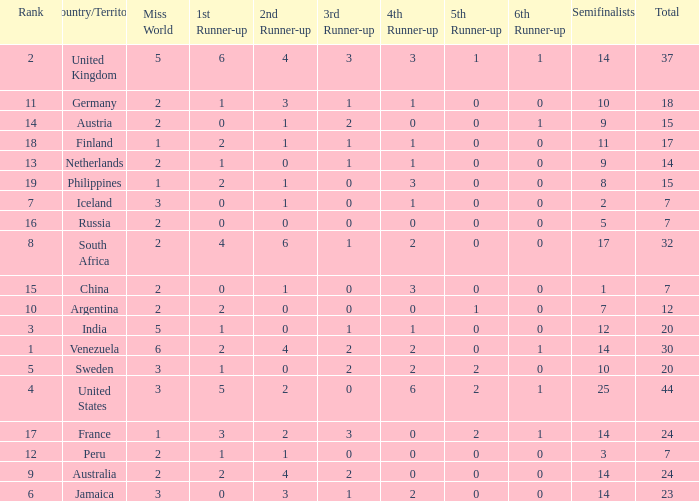Which countries have a 5th runner-up ranking is 2 and the 3rd runner-up ranking is 0 44.0. 